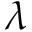Convert formula to latex. <formula><loc_0><loc_0><loc_500><loc_500>\lambda</formula> 